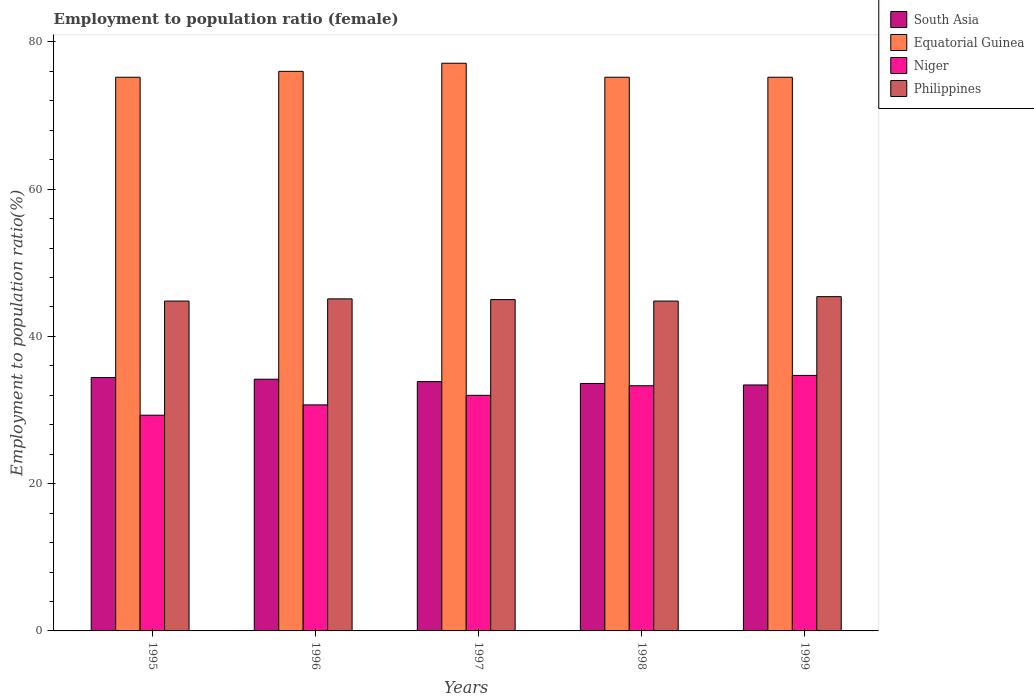How many different coloured bars are there?
Ensure brevity in your answer.  4. How many bars are there on the 5th tick from the left?
Provide a succinct answer. 4. What is the label of the 1st group of bars from the left?
Offer a terse response. 1995. In how many cases, is the number of bars for a given year not equal to the number of legend labels?
Make the answer very short. 0. What is the employment to population ratio in Niger in 1996?
Your response must be concise. 30.7. Across all years, what is the maximum employment to population ratio in Equatorial Guinea?
Provide a succinct answer. 77.1. Across all years, what is the minimum employment to population ratio in Niger?
Offer a very short reply. 29.3. What is the total employment to population ratio in South Asia in the graph?
Your answer should be compact. 169.48. What is the difference between the employment to population ratio in South Asia in 1995 and that in 1996?
Offer a terse response. 0.23. What is the difference between the employment to population ratio in South Asia in 1998 and the employment to population ratio in Equatorial Guinea in 1996?
Provide a short and direct response. -42.39. What is the average employment to population ratio in South Asia per year?
Offer a terse response. 33.9. In the year 1997, what is the difference between the employment to population ratio in South Asia and employment to population ratio in Niger?
Offer a terse response. 1.86. In how many years, is the employment to population ratio in Philippines greater than 48 %?
Keep it short and to the point. 0. What is the ratio of the employment to population ratio in South Asia in 1995 to that in 1997?
Offer a terse response. 1.02. Is the employment to population ratio in South Asia in 1995 less than that in 1996?
Keep it short and to the point. No. Is the difference between the employment to population ratio in South Asia in 1996 and 1997 greater than the difference between the employment to population ratio in Niger in 1996 and 1997?
Give a very brief answer. Yes. What is the difference between the highest and the second highest employment to population ratio in Equatorial Guinea?
Your answer should be compact. 1.1. What is the difference between the highest and the lowest employment to population ratio in South Asia?
Offer a terse response. 1.01. In how many years, is the employment to population ratio in Niger greater than the average employment to population ratio in Niger taken over all years?
Provide a succinct answer. 2. What does the 3rd bar from the left in 1997 represents?
Provide a succinct answer. Niger. What is the difference between two consecutive major ticks on the Y-axis?
Make the answer very short. 20. Are the values on the major ticks of Y-axis written in scientific E-notation?
Ensure brevity in your answer.  No. Where does the legend appear in the graph?
Your response must be concise. Top right. How many legend labels are there?
Your answer should be compact. 4. How are the legend labels stacked?
Ensure brevity in your answer.  Vertical. What is the title of the graph?
Provide a short and direct response. Employment to population ratio (female). What is the label or title of the X-axis?
Ensure brevity in your answer.  Years. What is the Employment to population ratio(%) in South Asia in 1995?
Provide a short and direct response. 34.41. What is the Employment to population ratio(%) in Equatorial Guinea in 1995?
Your response must be concise. 75.2. What is the Employment to population ratio(%) of Niger in 1995?
Your response must be concise. 29.3. What is the Employment to population ratio(%) of Philippines in 1995?
Keep it short and to the point. 44.8. What is the Employment to population ratio(%) of South Asia in 1996?
Offer a very short reply. 34.19. What is the Employment to population ratio(%) of Equatorial Guinea in 1996?
Make the answer very short. 76. What is the Employment to population ratio(%) in Niger in 1996?
Give a very brief answer. 30.7. What is the Employment to population ratio(%) of Philippines in 1996?
Give a very brief answer. 45.1. What is the Employment to population ratio(%) of South Asia in 1997?
Your answer should be very brief. 33.86. What is the Employment to population ratio(%) in Equatorial Guinea in 1997?
Your response must be concise. 77.1. What is the Employment to population ratio(%) of Niger in 1997?
Your answer should be compact. 32. What is the Employment to population ratio(%) in South Asia in 1998?
Keep it short and to the point. 33.61. What is the Employment to population ratio(%) of Equatorial Guinea in 1998?
Offer a very short reply. 75.2. What is the Employment to population ratio(%) in Niger in 1998?
Make the answer very short. 33.3. What is the Employment to population ratio(%) of Philippines in 1998?
Make the answer very short. 44.8. What is the Employment to population ratio(%) in South Asia in 1999?
Offer a terse response. 33.41. What is the Employment to population ratio(%) in Equatorial Guinea in 1999?
Ensure brevity in your answer.  75.2. What is the Employment to population ratio(%) of Niger in 1999?
Offer a very short reply. 34.7. What is the Employment to population ratio(%) of Philippines in 1999?
Keep it short and to the point. 45.4. Across all years, what is the maximum Employment to population ratio(%) of South Asia?
Offer a terse response. 34.41. Across all years, what is the maximum Employment to population ratio(%) in Equatorial Guinea?
Your response must be concise. 77.1. Across all years, what is the maximum Employment to population ratio(%) in Niger?
Make the answer very short. 34.7. Across all years, what is the maximum Employment to population ratio(%) in Philippines?
Keep it short and to the point. 45.4. Across all years, what is the minimum Employment to population ratio(%) of South Asia?
Your answer should be compact. 33.41. Across all years, what is the minimum Employment to population ratio(%) in Equatorial Guinea?
Offer a very short reply. 75.2. Across all years, what is the minimum Employment to population ratio(%) of Niger?
Provide a short and direct response. 29.3. Across all years, what is the minimum Employment to population ratio(%) in Philippines?
Give a very brief answer. 44.8. What is the total Employment to population ratio(%) in South Asia in the graph?
Provide a short and direct response. 169.48. What is the total Employment to population ratio(%) of Equatorial Guinea in the graph?
Make the answer very short. 378.7. What is the total Employment to population ratio(%) in Niger in the graph?
Make the answer very short. 160. What is the total Employment to population ratio(%) in Philippines in the graph?
Offer a very short reply. 225.1. What is the difference between the Employment to population ratio(%) of South Asia in 1995 and that in 1996?
Your answer should be compact. 0.23. What is the difference between the Employment to population ratio(%) in South Asia in 1995 and that in 1997?
Ensure brevity in your answer.  0.55. What is the difference between the Employment to population ratio(%) of Equatorial Guinea in 1995 and that in 1997?
Offer a very short reply. -1.9. What is the difference between the Employment to population ratio(%) of Niger in 1995 and that in 1997?
Give a very brief answer. -2.7. What is the difference between the Employment to population ratio(%) in Philippines in 1995 and that in 1997?
Provide a short and direct response. -0.2. What is the difference between the Employment to population ratio(%) in South Asia in 1995 and that in 1998?
Your response must be concise. 0.8. What is the difference between the Employment to population ratio(%) in Equatorial Guinea in 1995 and that in 1998?
Your answer should be very brief. 0. What is the difference between the Employment to population ratio(%) in Niger in 1995 and that in 1998?
Keep it short and to the point. -4. What is the difference between the Employment to population ratio(%) of Philippines in 1995 and that in 1998?
Offer a terse response. 0. What is the difference between the Employment to population ratio(%) in South Asia in 1995 and that in 1999?
Your answer should be very brief. 1.01. What is the difference between the Employment to population ratio(%) of Equatorial Guinea in 1995 and that in 1999?
Keep it short and to the point. 0. What is the difference between the Employment to population ratio(%) in South Asia in 1996 and that in 1997?
Your answer should be compact. 0.33. What is the difference between the Employment to population ratio(%) of Niger in 1996 and that in 1997?
Provide a succinct answer. -1.3. What is the difference between the Employment to population ratio(%) of Philippines in 1996 and that in 1997?
Make the answer very short. 0.1. What is the difference between the Employment to population ratio(%) of South Asia in 1996 and that in 1998?
Give a very brief answer. 0.58. What is the difference between the Employment to population ratio(%) of Equatorial Guinea in 1996 and that in 1998?
Make the answer very short. 0.8. What is the difference between the Employment to population ratio(%) in Niger in 1996 and that in 1998?
Give a very brief answer. -2.6. What is the difference between the Employment to population ratio(%) of South Asia in 1996 and that in 1999?
Make the answer very short. 0.78. What is the difference between the Employment to population ratio(%) in Niger in 1996 and that in 1999?
Your answer should be very brief. -4. What is the difference between the Employment to population ratio(%) of South Asia in 1997 and that in 1998?
Make the answer very short. 0.25. What is the difference between the Employment to population ratio(%) of Equatorial Guinea in 1997 and that in 1998?
Offer a terse response. 1.9. What is the difference between the Employment to population ratio(%) in Philippines in 1997 and that in 1998?
Keep it short and to the point. 0.2. What is the difference between the Employment to population ratio(%) in South Asia in 1997 and that in 1999?
Provide a short and direct response. 0.46. What is the difference between the Employment to population ratio(%) of Equatorial Guinea in 1997 and that in 1999?
Ensure brevity in your answer.  1.9. What is the difference between the Employment to population ratio(%) in Niger in 1997 and that in 1999?
Offer a very short reply. -2.7. What is the difference between the Employment to population ratio(%) of South Asia in 1998 and that in 1999?
Ensure brevity in your answer.  0.2. What is the difference between the Employment to population ratio(%) of Niger in 1998 and that in 1999?
Your answer should be very brief. -1.4. What is the difference between the Employment to population ratio(%) of South Asia in 1995 and the Employment to population ratio(%) of Equatorial Guinea in 1996?
Offer a terse response. -41.59. What is the difference between the Employment to population ratio(%) in South Asia in 1995 and the Employment to population ratio(%) in Niger in 1996?
Ensure brevity in your answer.  3.71. What is the difference between the Employment to population ratio(%) in South Asia in 1995 and the Employment to population ratio(%) in Philippines in 1996?
Offer a very short reply. -10.69. What is the difference between the Employment to population ratio(%) in Equatorial Guinea in 1995 and the Employment to population ratio(%) in Niger in 1996?
Offer a very short reply. 44.5. What is the difference between the Employment to population ratio(%) of Equatorial Guinea in 1995 and the Employment to population ratio(%) of Philippines in 1996?
Ensure brevity in your answer.  30.1. What is the difference between the Employment to population ratio(%) in Niger in 1995 and the Employment to population ratio(%) in Philippines in 1996?
Your answer should be compact. -15.8. What is the difference between the Employment to population ratio(%) in South Asia in 1995 and the Employment to population ratio(%) in Equatorial Guinea in 1997?
Your response must be concise. -42.69. What is the difference between the Employment to population ratio(%) of South Asia in 1995 and the Employment to population ratio(%) of Niger in 1997?
Offer a terse response. 2.41. What is the difference between the Employment to population ratio(%) of South Asia in 1995 and the Employment to population ratio(%) of Philippines in 1997?
Keep it short and to the point. -10.59. What is the difference between the Employment to population ratio(%) in Equatorial Guinea in 1995 and the Employment to population ratio(%) in Niger in 1997?
Give a very brief answer. 43.2. What is the difference between the Employment to population ratio(%) in Equatorial Guinea in 1995 and the Employment to population ratio(%) in Philippines in 1997?
Provide a short and direct response. 30.2. What is the difference between the Employment to population ratio(%) of Niger in 1995 and the Employment to population ratio(%) of Philippines in 1997?
Make the answer very short. -15.7. What is the difference between the Employment to population ratio(%) of South Asia in 1995 and the Employment to population ratio(%) of Equatorial Guinea in 1998?
Give a very brief answer. -40.79. What is the difference between the Employment to population ratio(%) in South Asia in 1995 and the Employment to population ratio(%) in Niger in 1998?
Offer a terse response. 1.11. What is the difference between the Employment to population ratio(%) in South Asia in 1995 and the Employment to population ratio(%) in Philippines in 1998?
Provide a succinct answer. -10.39. What is the difference between the Employment to population ratio(%) of Equatorial Guinea in 1995 and the Employment to population ratio(%) of Niger in 1998?
Your response must be concise. 41.9. What is the difference between the Employment to population ratio(%) in Equatorial Guinea in 1995 and the Employment to population ratio(%) in Philippines in 1998?
Give a very brief answer. 30.4. What is the difference between the Employment to population ratio(%) of Niger in 1995 and the Employment to population ratio(%) of Philippines in 1998?
Your answer should be compact. -15.5. What is the difference between the Employment to population ratio(%) of South Asia in 1995 and the Employment to population ratio(%) of Equatorial Guinea in 1999?
Offer a very short reply. -40.79. What is the difference between the Employment to population ratio(%) in South Asia in 1995 and the Employment to population ratio(%) in Niger in 1999?
Provide a succinct answer. -0.29. What is the difference between the Employment to population ratio(%) in South Asia in 1995 and the Employment to population ratio(%) in Philippines in 1999?
Ensure brevity in your answer.  -10.99. What is the difference between the Employment to population ratio(%) in Equatorial Guinea in 1995 and the Employment to population ratio(%) in Niger in 1999?
Give a very brief answer. 40.5. What is the difference between the Employment to population ratio(%) of Equatorial Guinea in 1995 and the Employment to population ratio(%) of Philippines in 1999?
Provide a short and direct response. 29.8. What is the difference between the Employment to population ratio(%) of Niger in 1995 and the Employment to population ratio(%) of Philippines in 1999?
Provide a succinct answer. -16.1. What is the difference between the Employment to population ratio(%) of South Asia in 1996 and the Employment to population ratio(%) of Equatorial Guinea in 1997?
Give a very brief answer. -42.91. What is the difference between the Employment to population ratio(%) in South Asia in 1996 and the Employment to population ratio(%) in Niger in 1997?
Provide a succinct answer. 2.19. What is the difference between the Employment to population ratio(%) in South Asia in 1996 and the Employment to population ratio(%) in Philippines in 1997?
Keep it short and to the point. -10.81. What is the difference between the Employment to population ratio(%) of Equatorial Guinea in 1996 and the Employment to population ratio(%) of Niger in 1997?
Offer a very short reply. 44. What is the difference between the Employment to population ratio(%) in Equatorial Guinea in 1996 and the Employment to population ratio(%) in Philippines in 1997?
Ensure brevity in your answer.  31. What is the difference between the Employment to population ratio(%) in Niger in 1996 and the Employment to population ratio(%) in Philippines in 1997?
Give a very brief answer. -14.3. What is the difference between the Employment to population ratio(%) of South Asia in 1996 and the Employment to population ratio(%) of Equatorial Guinea in 1998?
Ensure brevity in your answer.  -41.01. What is the difference between the Employment to population ratio(%) of South Asia in 1996 and the Employment to population ratio(%) of Philippines in 1998?
Provide a short and direct response. -10.61. What is the difference between the Employment to population ratio(%) in Equatorial Guinea in 1996 and the Employment to population ratio(%) in Niger in 1998?
Offer a terse response. 42.7. What is the difference between the Employment to population ratio(%) of Equatorial Guinea in 1996 and the Employment to population ratio(%) of Philippines in 1998?
Offer a terse response. 31.2. What is the difference between the Employment to population ratio(%) of Niger in 1996 and the Employment to population ratio(%) of Philippines in 1998?
Ensure brevity in your answer.  -14.1. What is the difference between the Employment to population ratio(%) of South Asia in 1996 and the Employment to population ratio(%) of Equatorial Guinea in 1999?
Ensure brevity in your answer.  -41.01. What is the difference between the Employment to population ratio(%) in South Asia in 1996 and the Employment to population ratio(%) in Niger in 1999?
Make the answer very short. -0.51. What is the difference between the Employment to population ratio(%) of South Asia in 1996 and the Employment to population ratio(%) of Philippines in 1999?
Your answer should be compact. -11.21. What is the difference between the Employment to population ratio(%) of Equatorial Guinea in 1996 and the Employment to population ratio(%) of Niger in 1999?
Keep it short and to the point. 41.3. What is the difference between the Employment to population ratio(%) in Equatorial Guinea in 1996 and the Employment to population ratio(%) in Philippines in 1999?
Give a very brief answer. 30.6. What is the difference between the Employment to population ratio(%) in Niger in 1996 and the Employment to population ratio(%) in Philippines in 1999?
Provide a succinct answer. -14.7. What is the difference between the Employment to population ratio(%) in South Asia in 1997 and the Employment to population ratio(%) in Equatorial Guinea in 1998?
Offer a terse response. -41.34. What is the difference between the Employment to population ratio(%) in South Asia in 1997 and the Employment to population ratio(%) in Niger in 1998?
Provide a succinct answer. 0.56. What is the difference between the Employment to population ratio(%) of South Asia in 1997 and the Employment to population ratio(%) of Philippines in 1998?
Ensure brevity in your answer.  -10.94. What is the difference between the Employment to population ratio(%) in Equatorial Guinea in 1997 and the Employment to population ratio(%) in Niger in 1998?
Keep it short and to the point. 43.8. What is the difference between the Employment to population ratio(%) in Equatorial Guinea in 1997 and the Employment to population ratio(%) in Philippines in 1998?
Your answer should be compact. 32.3. What is the difference between the Employment to population ratio(%) of South Asia in 1997 and the Employment to population ratio(%) of Equatorial Guinea in 1999?
Your response must be concise. -41.34. What is the difference between the Employment to population ratio(%) of South Asia in 1997 and the Employment to population ratio(%) of Niger in 1999?
Your response must be concise. -0.84. What is the difference between the Employment to population ratio(%) in South Asia in 1997 and the Employment to population ratio(%) in Philippines in 1999?
Offer a terse response. -11.54. What is the difference between the Employment to population ratio(%) of Equatorial Guinea in 1997 and the Employment to population ratio(%) of Niger in 1999?
Keep it short and to the point. 42.4. What is the difference between the Employment to population ratio(%) of Equatorial Guinea in 1997 and the Employment to population ratio(%) of Philippines in 1999?
Offer a terse response. 31.7. What is the difference between the Employment to population ratio(%) in South Asia in 1998 and the Employment to population ratio(%) in Equatorial Guinea in 1999?
Provide a short and direct response. -41.59. What is the difference between the Employment to population ratio(%) in South Asia in 1998 and the Employment to population ratio(%) in Niger in 1999?
Your response must be concise. -1.09. What is the difference between the Employment to population ratio(%) in South Asia in 1998 and the Employment to population ratio(%) in Philippines in 1999?
Offer a terse response. -11.79. What is the difference between the Employment to population ratio(%) in Equatorial Guinea in 1998 and the Employment to population ratio(%) in Niger in 1999?
Keep it short and to the point. 40.5. What is the difference between the Employment to population ratio(%) in Equatorial Guinea in 1998 and the Employment to population ratio(%) in Philippines in 1999?
Your answer should be very brief. 29.8. What is the difference between the Employment to population ratio(%) in Niger in 1998 and the Employment to population ratio(%) in Philippines in 1999?
Give a very brief answer. -12.1. What is the average Employment to population ratio(%) in South Asia per year?
Ensure brevity in your answer.  33.9. What is the average Employment to population ratio(%) in Equatorial Guinea per year?
Make the answer very short. 75.74. What is the average Employment to population ratio(%) of Niger per year?
Offer a very short reply. 32. What is the average Employment to population ratio(%) in Philippines per year?
Give a very brief answer. 45.02. In the year 1995, what is the difference between the Employment to population ratio(%) of South Asia and Employment to population ratio(%) of Equatorial Guinea?
Ensure brevity in your answer.  -40.79. In the year 1995, what is the difference between the Employment to population ratio(%) in South Asia and Employment to population ratio(%) in Niger?
Offer a very short reply. 5.11. In the year 1995, what is the difference between the Employment to population ratio(%) in South Asia and Employment to population ratio(%) in Philippines?
Provide a short and direct response. -10.39. In the year 1995, what is the difference between the Employment to population ratio(%) in Equatorial Guinea and Employment to population ratio(%) in Niger?
Offer a very short reply. 45.9. In the year 1995, what is the difference between the Employment to population ratio(%) in Equatorial Guinea and Employment to population ratio(%) in Philippines?
Provide a short and direct response. 30.4. In the year 1995, what is the difference between the Employment to population ratio(%) in Niger and Employment to population ratio(%) in Philippines?
Make the answer very short. -15.5. In the year 1996, what is the difference between the Employment to population ratio(%) of South Asia and Employment to population ratio(%) of Equatorial Guinea?
Provide a succinct answer. -41.81. In the year 1996, what is the difference between the Employment to population ratio(%) in South Asia and Employment to population ratio(%) in Niger?
Offer a terse response. 3.49. In the year 1996, what is the difference between the Employment to population ratio(%) in South Asia and Employment to population ratio(%) in Philippines?
Provide a succinct answer. -10.91. In the year 1996, what is the difference between the Employment to population ratio(%) in Equatorial Guinea and Employment to population ratio(%) in Niger?
Your answer should be very brief. 45.3. In the year 1996, what is the difference between the Employment to population ratio(%) in Equatorial Guinea and Employment to population ratio(%) in Philippines?
Your answer should be very brief. 30.9. In the year 1996, what is the difference between the Employment to population ratio(%) in Niger and Employment to population ratio(%) in Philippines?
Your answer should be compact. -14.4. In the year 1997, what is the difference between the Employment to population ratio(%) of South Asia and Employment to population ratio(%) of Equatorial Guinea?
Provide a short and direct response. -43.24. In the year 1997, what is the difference between the Employment to population ratio(%) of South Asia and Employment to population ratio(%) of Niger?
Make the answer very short. 1.86. In the year 1997, what is the difference between the Employment to population ratio(%) of South Asia and Employment to population ratio(%) of Philippines?
Make the answer very short. -11.14. In the year 1997, what is the difference between the Employment to population ratio(%) of Equatorial Guinea and Employment to population ratio(%) of Niger?
Offer a terse response. 45.1. In the year 1997, what is the difference between the Employment to population ratio(%) in Equatorial Guinea and Employment to population ratio(%) in Philippines?
Provide a succinct answer. 32.1. In the year 1998, what is the difference between the Employment to population ratio(%) of South Asia and Employment to population ratio(%) of Equatorial Guinea?
Offer a terse response. -41.59. In the year 1998, what is the difference between the Employment to population ratio(%) in South Asia and Employment to population ratio(%) in Niger?
Keep it short and to the point. 0.31. In the year 1998, what is the difference between the Employment to population ratio(%) of South Asia and Employment to population ratio(%) of Philippines?
Make the answer very short. -11.19. In the year 1998, what is the difference between the Employment to population ratio(%) in Equatorial Guinea and Employment to population ratio(%) in Niger?
Offer a very short reply. 41.9. In the year 1998, what is the difference between the Employment to population ratio(%) of Equatorial Guinea and Employment to population ratio(%) of Philippines?
Make the answer very short. 30.4. In the year 1998, what is the difference between the Employment to population ratio(%) in Niger and Employment to population ratio(%) in Philippines?
Provide a short and direct response. -11.5. In the year 1999, what is the difference between the Employment to population ratio(%) in South Asia and Employment to population ratio(%) in Equatorial Guinea?
Offer a terse response. -41.79. In the year 1999, what is the difference between the Employment to population ratio(%) of South Asia and Employment to population ratio(%) of Niger?
Ensure brevity in your answer.  -1.29. In the year 1999, what is the difference between the Employment to population ratio(%) in South Asia and Employment to population ratio(%) in Philippines?
Keep it short and to the point. -11.99. In the year 1999, what is the difference between the Employment to population ratio(%) of Equatorial Guinea and Employment to population ratio(%) of Niger?
Provide a short and direct response. 40.5. In the year 1999, what is the difference between the Employment to population ratio(%) of Equatorial Guinea and Employment to population ratio(%) of Philippines?
Your answer should be very brief. 29.8. In the year 1999, what is the difference between the Employment to population ratio(%) in Niger and Employment to population ratio(%) in Philippines?
Offer a terse response. -10.7. What is the ratio of the Employment to population ratio(%) in South Asia in 1995 to that in 1996?
Your response must be concise. 1.01. What is the ratio of the Employment to population ratio(%) in Niger in 1995 to that in 1996?
Ensure brevity in your answer.  0.95. What is the ratio of the Employment to population ratio(%) in South Asia in 1995 to that in 1997?
Give a very brief answer. 1.02. What is the ratio of the Employment to population ratio(%) of Equatorial Guinea in 1995 to that in 1997?
Your answer should be compact. 0.98. What is the ratio of the Employment to population ratio(%) of Niger in 1995 to that in 1997?
Keep it short and to the point. 0.92. What is the ratio of the Employment to population ratio(%) in Philippines in 1995 to that in 1997?
Offer a terse response. 1. What is the ratio of the Employment to population ratio(%) in South Asia in 1995 to that in 1998?
Your answer should be compact. 1.02. What is the ratio of the Employment to population ratio(%) in Equatorial Guinea in 1995 to that in 1998?
Your answer should be very brief. 1. What is the ratio of the Employment to population ratio(%) in Niger in 1995 to that in 1998?
Keep it short and to the point. 0.88. What is the ratio of the Employment to population ratio(%) of South Asia in 1995 to that in 1999?
Your answer should be very brief. 1.03. What is the ratio of the Employment to population ratio(%) of Niger in 1995 to that in 1999?
Provide a short and direct response. 0.84. What is the ratio of the Employment to population ratio(%) in South Asia in 1996 to that in 1997?
Provide a succinct answer. 1.01. What is the ratio of the Employment to population ratio(%) in Equatorial Guinea in 1996 to that in 1997?
Provide a succinct answer. 0.99. What is the ratio of the Employment to population ratio(%) of Niger in 1996 to that in 1997?
Your answer should be very brief. 0.96. What is the ratio of the Employment to population ratio(%) in South Asia in 1996 to that in 1998?
Your response must be concise. 1.02. What is the ratio of the Employment to population ratio(%) in Equatorial Guinea in 1996 to that in 1998?
Give a very brief answer. 1.01. What is the ratio of the Employment to population ratio(%) of Niger in 1996 to that in 1998?
Make the answer very short. 0.92. What is the ratio of the Employment to population ratio(%) in Philippines in 1996 to that in 1998?
Your answer should be compact. 1.01. What is the ratio of the Employment to population ratio(%) of South Asia in 1996 to that in 1999?
Your answer should be compact. 1.02. What is the ratio of the Employment to population ratio(%) in Equatorial Guinea in 1996 to that in 1999?
Keep it short and to the point. 1.01. What is the ratio of the Employment to population ratio(%) of Niger in 1996 to that in 1999?
Make the answer very short. 0.88. What is the ratio of the Employment to population ratio(%) in Philippines in 1996 to that in 1999?
Give a very brief answer. 0.99. What is the ratio of the Employment to population ratio(%) of South Asia in 1997 to that in 1998?
Make the answer very short. 1.01. What is the ratio of the Employment to population ratio(%) of Equatorial Guinea in 1997 to that in 1998?
Offer a very short reply. 1.03. What is the ratio of the Employment to population ratio(%) of Niger in 1997 to that in 1998?
Provide a succinct answer. 0.96. What is the ratio of the Employment to population ratio(%) of South Asia in 1997 to that in 1999?
Provide a short and direct response. 1.01. What is the ratio of the Employment to population ratio(%) in Equatorial Guinea in 1997 to that in 1999?
Offer a very short reply. 1.03. What is the ratio of the Employment to population ratio(%) in Niger in 1997 to that in 1999?
Your answer should be very brief. 0.92. What is the ratio of the Employment to population ratio(%) of Philippines in 1997 to that in 1999?
Keep it short and to the point. 0.99. What is the ratio of the Employment to population ratio(%) of South Asia in 1998 to that in 1999?
Give a very brief answer. 1.01. What is the ratio of the Employment to population ratio(%) of Niger in 1998 to that in 1999?
Offer a very short reply. 0.96. What is the difference between the highest and the second highest Employment to population ratio(%) in South Asia?
Your response must be concise. 0.23. What is the difference between the highest and the second highest Employment to population ratio(%) of Equatorial Guinea?
Offer a terse response. 1.1. What is the difference between the highest and the second highest Employment to population ratio(%) in Niger?
Offer a very short reply. 1.4. What is the difference between the highest and the lowest Employment to population ratio(%) of South Asia?
Make the answer very short. 1.01. What is the difference between the highest and the lowest Employment to population ratio(%) of Equatorial Guinea?
Keep it short and to the point. 1.9. 